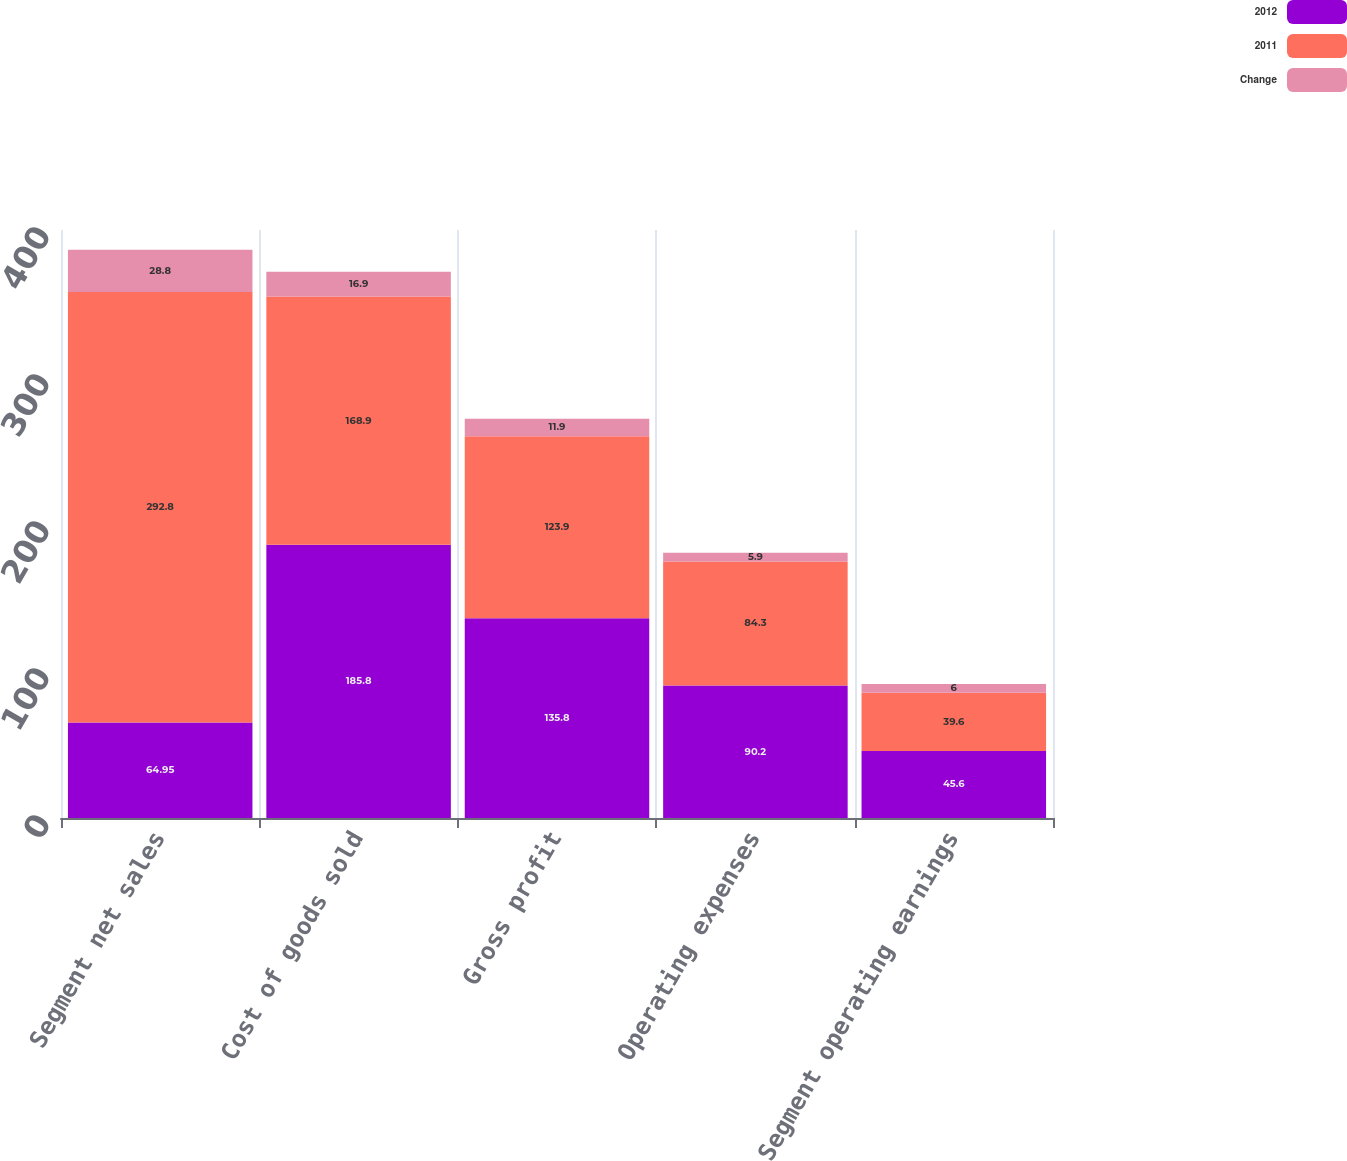Convert chart. <chart><loc_0><loc_0><loc_500><loc_500><stacked_bar_chart><ecel><fcel>Segment net sales<fcel>Cost of goods sold<fcel>Gross profit<fcel>Operating expenses<fcel>Segment operating earnings<nl><fcel>2012<fcel>64.95<fcel>185.8<fcel>135.8<fcel>90.2<fcel>45.6<nl><fcel>2011<fcel>292.8<fcel>168.9<fcel>123.9<fcel>84.3<fcel>39.6<nl><fcel>Change<fcel>28.8<fcel>16.9<fcel>11.9<fcel>5.9<fcel>6<nl></chart> 